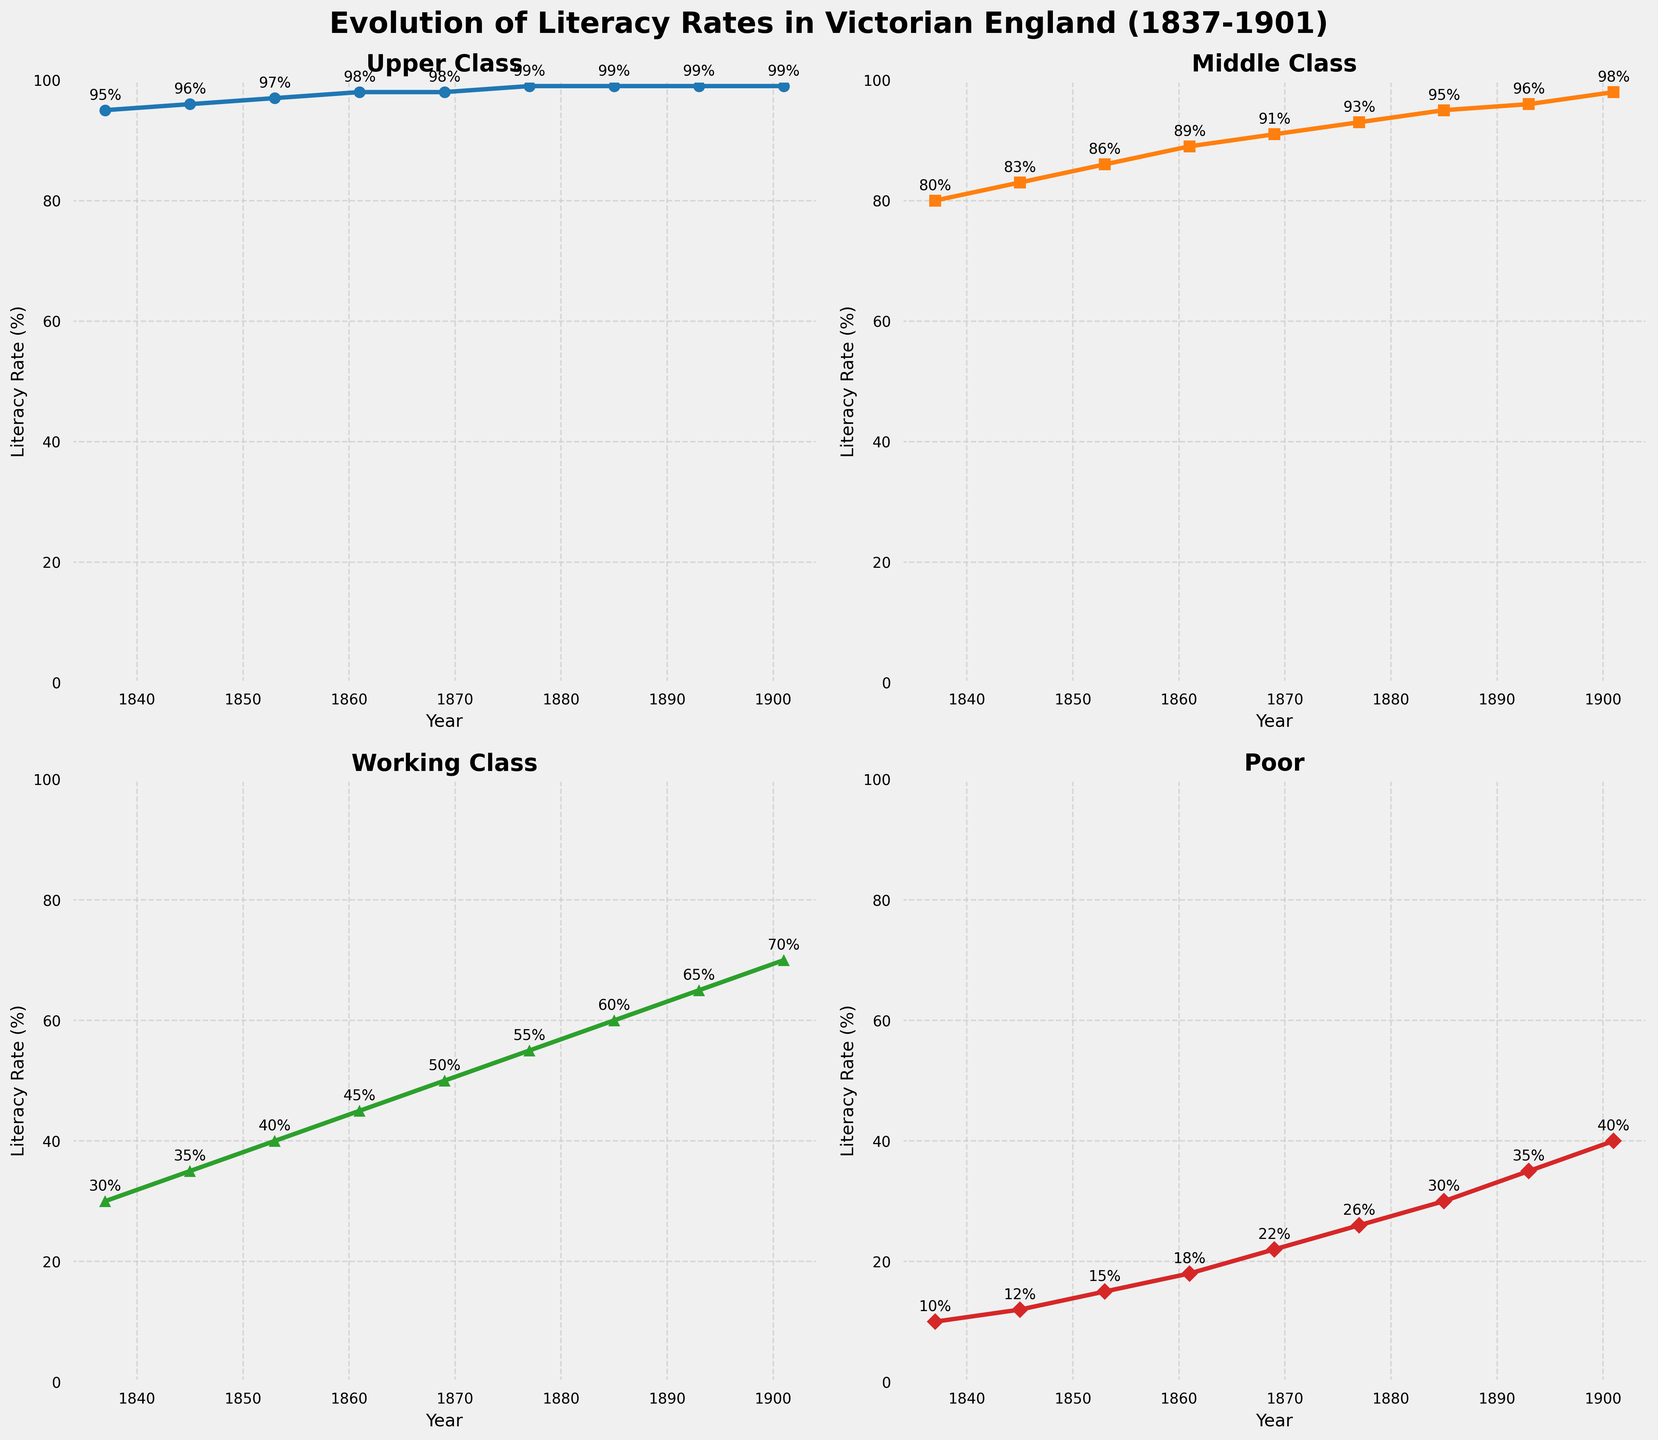What was the literacy rate for the Middle Class in 1853? Look at the subplot for the Middle Class and find the data point corresponding to the year 1853.
Answer: 86% Which social class had the highest literacy rate in 1845, and what was it? Check each subplot for the year 1845 and compare the literacy rates. The Upper Class had the highest rate.
Answer: Upper Class, 96% Between the years 1885 and 1901, which class experienced the largest increase in literacy rate and by how much? Calculate the difference in literacy rates for each class between 1885 and 1901. The Working Class saw the largest increase: 70 - 60.
Answer: Working Class, 10% How would you describe the trend in literacy rates for the Poor from 1837 to 1901? Observe the subplot for the Poor and note the overall increase from 10% to 40%.
Answer: Steady increase What is the average literacy rate of the Middle Class across all years shown? Calculate the average of Middle Class literacy rates: (80 + 83 + 86 + 89 + 91 + 93 + 95 + 96 + 98) / 9 = 90.1%
Answer: 90.1% In which decade did the Working Class literacy rate surpass 50%? Look at the Working Class subplot and find when the literacy rate exceeds 50% (between 1861 and 1869).
Answer: 1860s Which class had the smallest increase in literacy rate from 1837 to 1901, and what was the increase? Calculate the increase for each class: Upper Class (99 - 95), Middle Class (98 - 80), Working Class (70 - 30), Poor (40 - 10). The Upper Class had the smallest increase, from 95% to 99%.
Answer: Upper Class, 4% Do any of the classes reach a literacy rate of 100%? Check each subplot to see if any line reaches 100%. No class does.
Answer: No Between which two years did the Poor experience the greatest increase in literacy rate? Find the largest yearly increase in the Poor subplot. The biggest jump is from 1893 to 1901 (35 to 40).
Answer: 1893 to 1901 